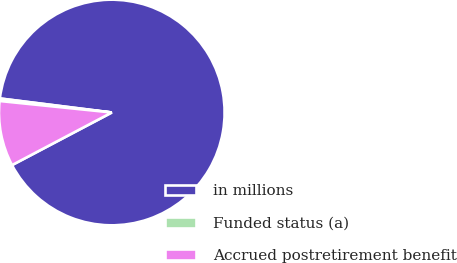<chart> <loc_0><loc_0><loc_500><loc_500><pie_chart><fcel>in millions<fcel>Funded status (a)<fcel>Accrued postretirement benefit<nl><fcel>90.29%<fcel>0.36%<fcel>9.35%<nl></chart> 